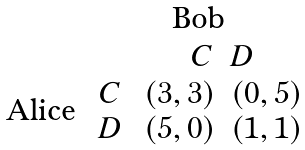Convert formula to latex. <formula><loc_0><loc_0><loc_500><loc_500>\begin{array} { c } \text {Alice} \end{array} \stackrel { \begin{array} { c } \text {Bob} \end{array} } { \begin{array} { c } C \\ D \end{array} \stackrel { \begin{array} { c c } C & D \end{array} } { \begin{array} { c c } ( 3 , 3 ) & ( 0 , 5 ) \\ ( 5 , 0 ) & ( 1 , 1 ) \end{array} } }</formula> 